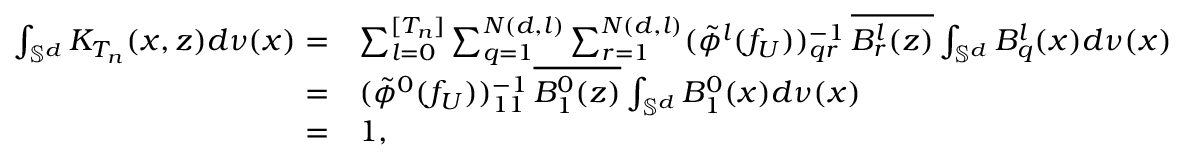<formula> <loc_0><loc_0><loc_500><loc_500>\begin{array} { r l } { \int _ { \mathbb { S } ^ { d } } K _ { T _ { n } } ( x , z ) d \nu ( x ) = } & { \sum _ { l = 0 } ^ { [ T _ { n } ] } \sum _ { q = 1 } ^ { N ( d , l ) } \sum _ { r = 1 } ^ { N ( d , l ) } ( \tilde { \phi } ^ { l } ( f _ { U } ) ) _ { q r } ^ { - 1 } \, \overline { { B _ { r } ^ { l } ( z ) } } \int _ { \mathbb { S } ^ { d } } B _ { q } ^ { l } ( x ) d \nu ( x ) } \\ { = } & { ( \tilde { \phi } ^ { 0 } ( f _ { U } ) ) _ { 1 1 } ^ { - 1 } \, \overline { { B _ { 1 } ^ { 0 } ( z ) } } \int _ { \mathbb { S } ^ { d } } B _ { 1 } ^ { 0 } ( x ) d \nu ( x ) } \\ { = } & { 1 , } \end{array}</formula> 